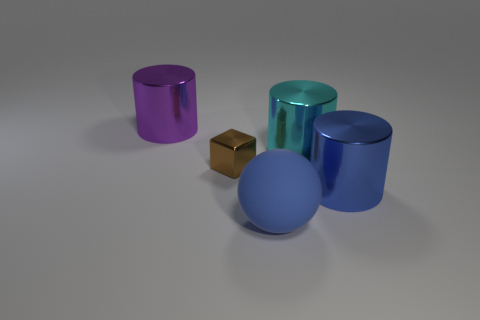Subtract 1 cylinders. How many cylinders are left? 2 Add 4 large purple cylinders. How many objects exist? 9 Subtract all spheres. How many objects are left? 4 Subtract 1 blue spheres. How many objects are left? 4 Subtract all brown cubes. Subtract all cylinders. How many objects are left? 1 Add 1 big cyan metal things. How many big cyan metal things are left? 2 Add 2 purple metal cylinders. How many purple metal cylinders exist? 3 